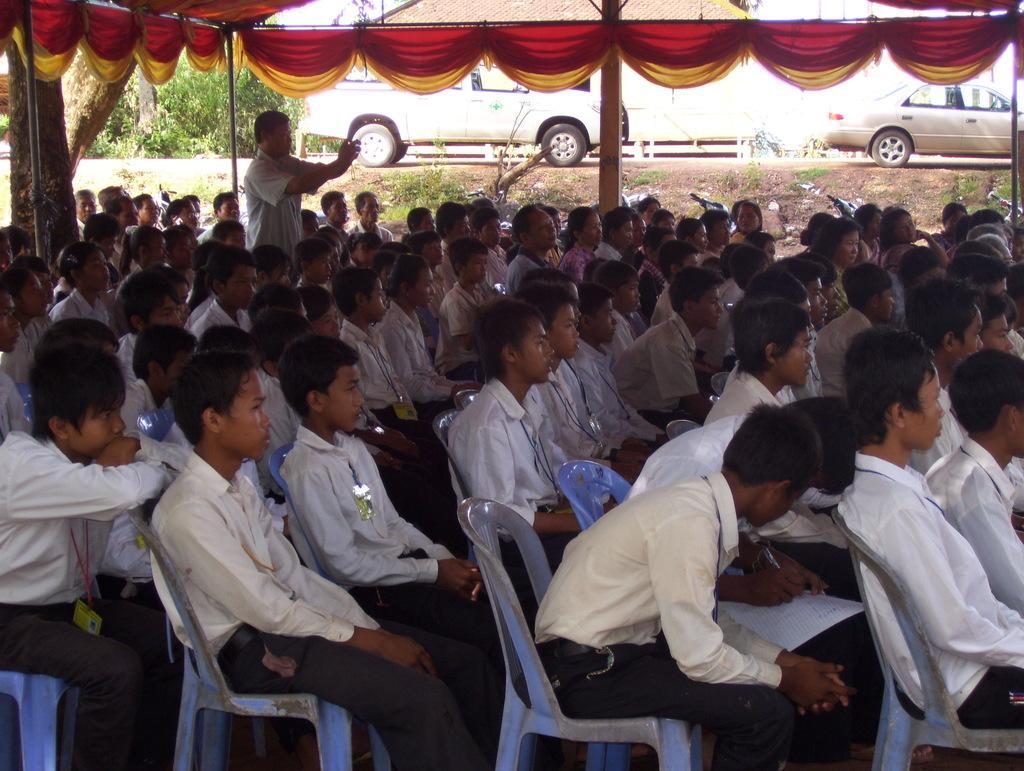In one or two sentences, can you explain what this image depicts? In this image we can see group of people are sitting on the chairs and there is a man standing. Here we can see decorative clothes and poles. In the background we can see vehicles and trees. 